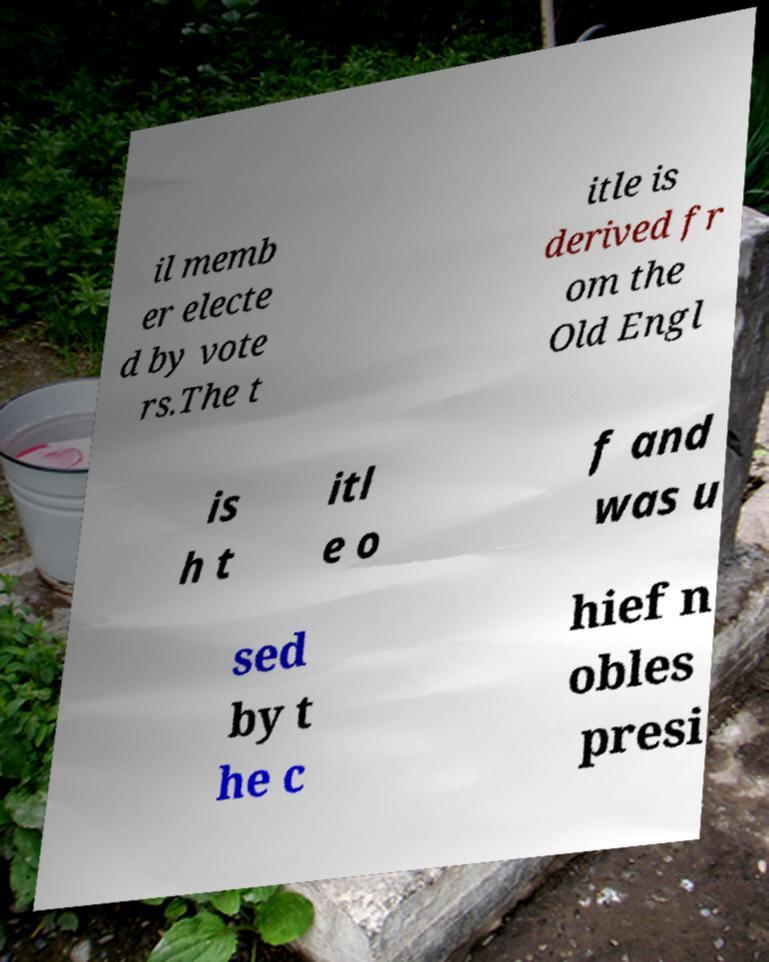Please read and relay the text visible in this image. What does it say? il memb er electe d by vote rs.The t itle is derived fr om the Old Engl is h t itl e o f and was u sed by t he c hief n obles presi 